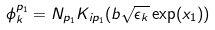Convert formula to latex. <formula><loc_0><loc_0><loc_500><loc_500>\phi _ { k } ^ { p _ { 1 } } = N _ { p _ { 1 } } K _ { i p _ { 1 } } ( b \sqrt { \epsilon _ { k } } \exp ( x _ { 1 } ) )</formula> 